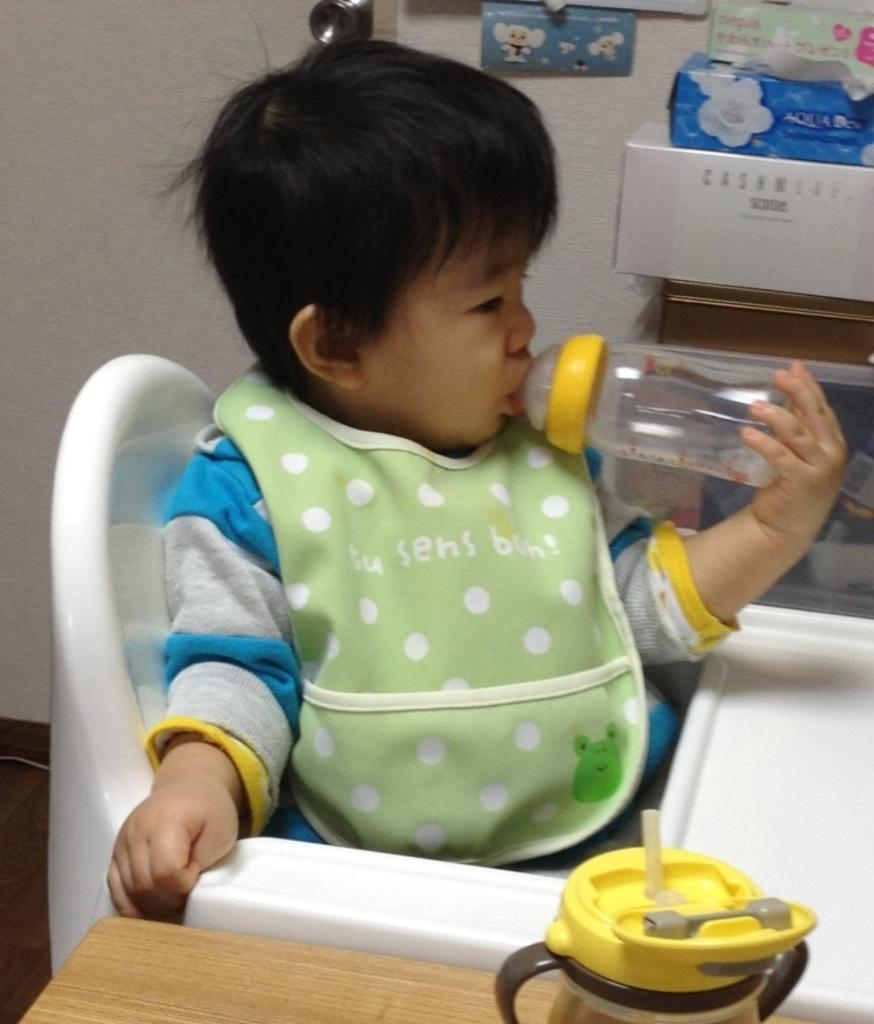What is the main subject of the image? The main subject of the image is a kid. What is the kid doing in the image? The kid is sitting on a baby dining chair and holding a bottle. Can you describe the objects near the kid? There is another bottle at the bottom of the image. What can be seen in the background of the image? There is a wall and boxes in the background of the image. What type of country is depicted in the image? There is no country depicted in the image; it features a kid sitting on a baby dining chair and holding a bottle. How many markets can be seen in the image? There are no markets present in the image. 